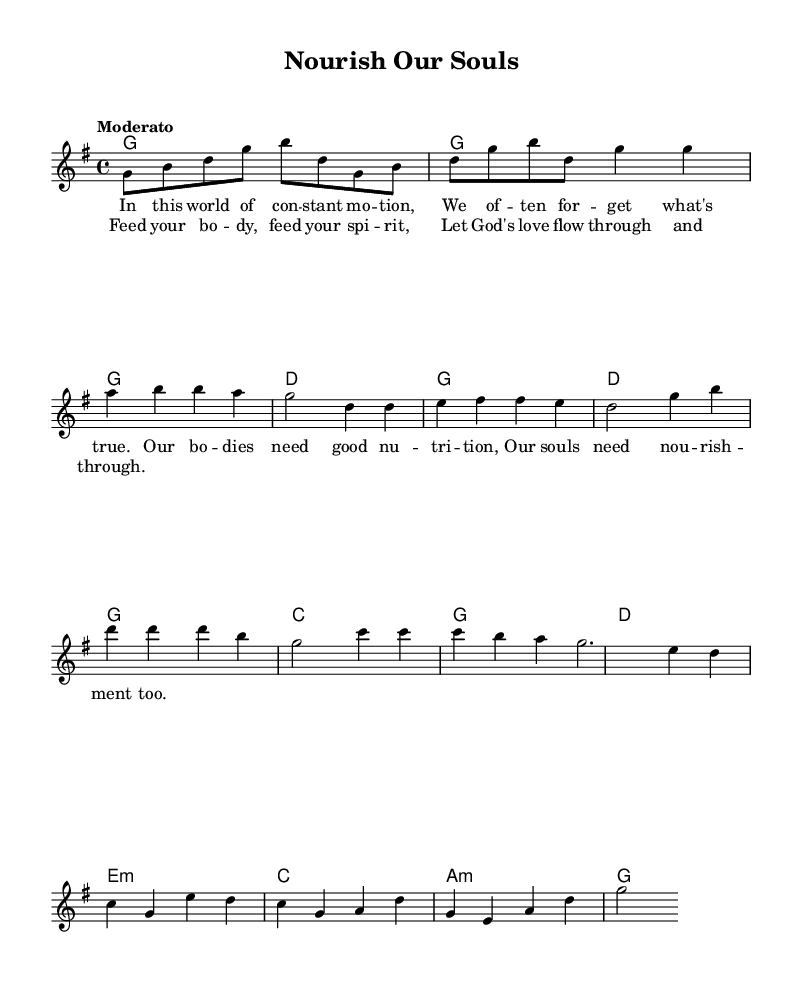What is the key signature of this music? The key signature is indicated at the beginning of the staff, showing that there is an F sharp, which means the piece is in G major.
Answer: G major What is the time signature of this music? The time signature is displayed at the start of the piece, which shows 4/4, meaning there are four beats in each measure.
Answer: 4/4 What is the tempo marking for this piece? The tempo marking is shown in Italian at the beginning of the music as "Moderato," indicating a moderate speed for playing.
Answer: Moderato How many measures are in the chorus? To count the measures, we look at the chorus section within the score, which has a total of 4 measures as separated by bar lines.
Answer: 4 What are the first lyrics of the verse? The first lyrics can be seen in the lyric section under the melody staff, which starts with "In this world of constant motion," indicating the beginning of the verse.
Answer: In this world of constant motion What is the chord for the first measure? In the first measure of the chord section, the chord is identified as G which is indicated by the letter in that measure.
Answer: G What is the primary theme of the song based on the lyrics? The lyrics convey the importance of nourishing both body and spirit, suggesting a dual role of nutrition and spiritual nourishment.
Answer: Nourishing body and spirit 